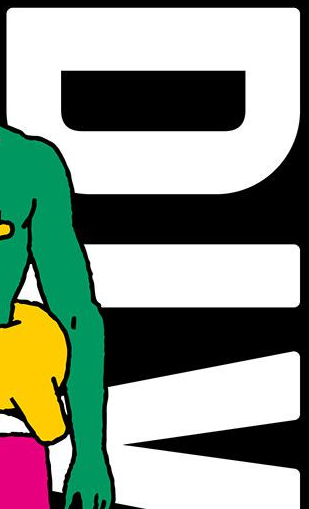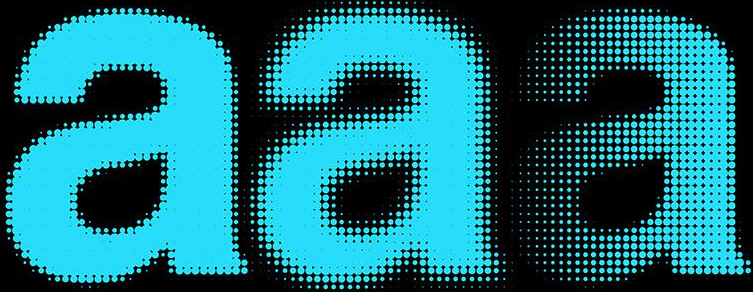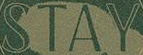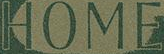Transcribe the words shown in these images in order, separated by a semicolon. DIV; aaa; STAY; HOME 